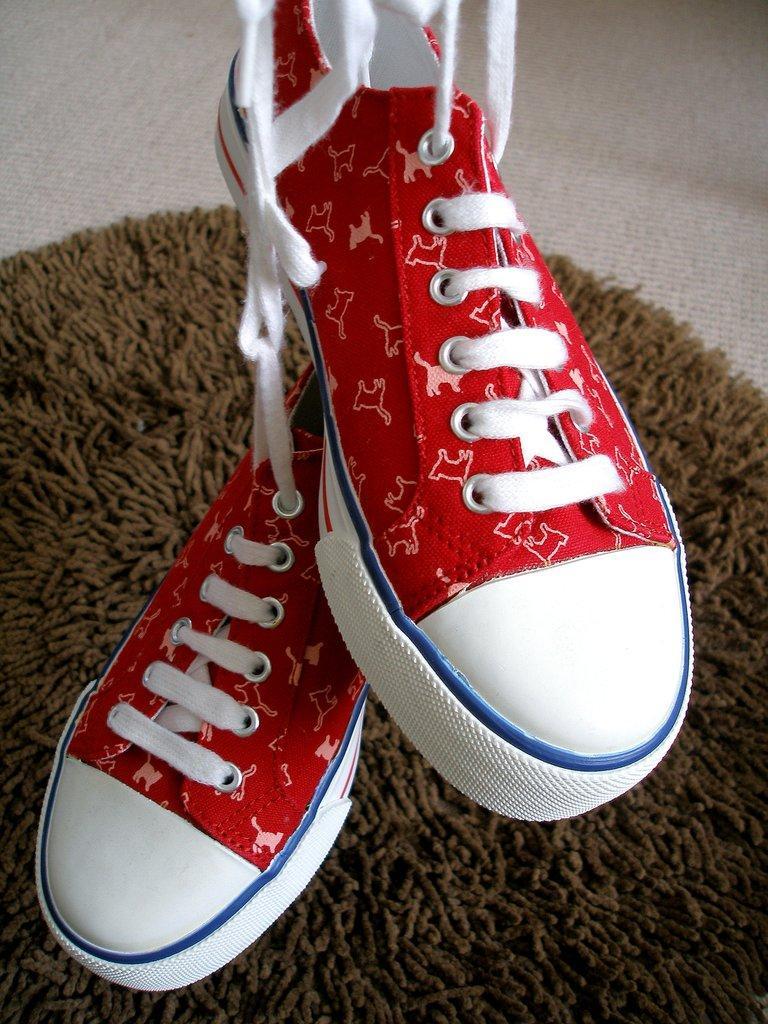Describe this image in one or two sentences. In this picture we can see shoes and mat on the floor. 